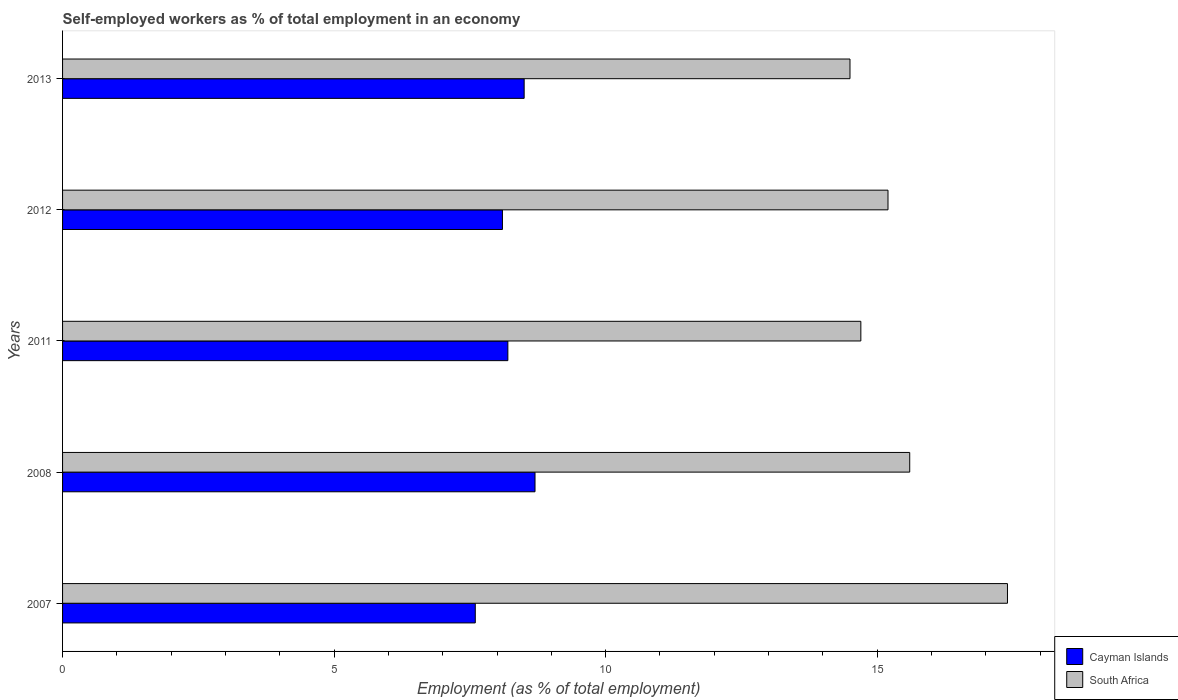How many different coloured bars are there?
Give a very brief answer. 2. How many groups of bars are there?
Make the answer very short. 5. Are the number of bars on each tick of the Y-axis equal?
Give a very brief answer. Yes. How many bars are there on the 4th tick from the top?
Provide a short and direct response. 2. What is the label of the 2nd group of bars from the top?
Provide a short and direct response. 2012. In how many cases, is the number of bars for a given year not equal to the number of legend labels?
Keep it short and to the point. 0. What is the percentage of self-employed workers in South Africa in 2011?
Your response must be concise. 14.7. Across all years, what is the maximum percentage of self-employed workers in South Africa?
Your answer should be very brief. 17.4. In which year was the percentage of self-employed workers in Cayman Islands maximum?
Make the answer very short. 2008. What is the total percentage of self-employed workers in Cayman Islands in the graph?
Make the answer very short. 41.1. What is the difference between the percentage of self-employed workers in Cayman Islands in 2008 and that in 2013?
Keep it short and to the point. 0.2. What is the difference between the percentage of self-employed workers in Cayman Islands in 2007 and the percentage of self-employed workers in South Africa in 2013?
Ensure brevity in your answer.  -6.9. What is the average percentage of self-employed workers in Cayman Islands per year?
Your answer should be compact. 8.22. In the year 2007, what is the difference between the percentage of self-employed workers in South Africa and percentage of self-employed workers in Cayman Islands?
Provide a short and direct response. 9.8. What is the ratio of the percentage of self-employed workers in Cayman Islands in 2011 to that in 2012?
Your answer should be very brief. 1.01. What is the difference between the highest and the second highest percentage of self-employed workers in South Africa?
Keep it short and to the point. 1.8. What is the difference between the highest and the lowest percentage of self-employed workers in South Africa?
Your response must be concise. 2.9. Is the sum of the percentage of self-employed workers in Cayman Islands in 2012 and 2013 greater than the maximum percentage of self-employed workers in South Africa across all years?
Your answer should be very brief. No. What does the 1st bar from the top in 2008 represents?
Keep it short and to the point. South Africa. What does the 2nd bar from the bottom in 2012 represents?
Give a very brief answer. South Africa. How many bars are there?
Provide a succinct answer. 10. Are all the bars in the graph horizontal?
Your response must be concise. Yes. How many years are there in the graph?
Your answer should be compact. 5. Are the values on the major ticks of X-axis written in scientific E-notation?
Your answer should be compact. No. How are the legend labels stacked?
Offer a very short reply. Vertical. What is the title of the graph?
Give a very brief answer. Self-employed workers as % of total employment in an economy. Does "United Kingdom" appear as one of the legend labels in the graph?
Make the answer very short. No. What is the label or title of the X-axis?
Your answer should be very brief. Employment (as % of total employment). What is the Employment (as % of total employment) in Cayman Islands in 2007?
Ensure brevity in your answer.  7.6. What is the Employment (as % of total employment) of South Africa in 2007?
Provide a succinct answer. 17.4. What is the Employment (as % of total employment) of Cayman Islands in 2008?
Ensure brevity in your answer.  8.7. What is the Employment (as % of total employment) of South Africa in 2008?
Your answer should be compact. 15.6. What is the Employment (as % of total employment) in Cayman Islands in 2011?
Make the answer very short. 8.2. What is the Employment (as % of total employment) in South Africa in 2011?
Offer a very short reply. 14.7. What is the Employment (as % of total employment) of Cayman Islands in 2012?
Give a very brief answer. 8.1. What is the Employment (as % of total employment) of South Africa in 2012?
Provide a short and direct response. 15.2. What is the Employment (as % of total employment) in Cayman Islands in 2013?
Ensure brevity in your answer.  8.5. Across all years, what is the maximum Employment (as % of total employment) of Cayman Islands?
Your response must be concise. 8.7. Across all years, what is the maximum Employment (as % of total employment) in South Africa?
Your response must be concise. 17.4. Across all years, what is the minimum Employment (as % of total employment) of Cayman Islands?
Offer a terse response. 7.6. Across all years, what is the minimum Employment (as % of total employment) in South Africa?
Your response must be concise. 14.5. What is the total Employment (as % of total employment) in Cayman Islands in the graph?
Your answer should be very brief. 41.1. What is the total Employment (as % of total employment) in South Africa in the graph?
Your answer should be very brief. 77.4. What is the difference between the Employment (as % of total employment) in Cayman Islands in 2007 and that in 2011?
Your answer should be compact. -0.6. What is the difference between the Employment (as % of total employment) in Cayman Islands in 2008 and that in 2011?
Provide a short and direct response. 0.5. What is the difference between the Employment (as % of total employment) in South Africa in 2008 and that in 2011?
Give a very brief answer. 0.9. What is the difference between the Employment (as % of total employment) of South Africa in 2011 and that in 2012?
Offer a terse response. -0.5. What is the difference between the Employment (as % of total employment) of South Africa in 2011 and that in 2013?
Offer a very short reply. 0.2. What is the difference between the Employment (as % of total employment) in Cayman Islands in 2012 and that in 2013?
Keep it short and to the point. -0.4. What is the difference between the Employment (as % of total employment) in South Africa in 2012 and that in 2013?
Your response must be concise. 0.7. What is the difference between the Employment (as % of total employment) of Cayman Islands in 2007 and the Employment (as % of total employment) of South Africa in 2008?
Your response must be concise. -8. What is the difference between the Employment (as % of total employment) of Cayman Islands in 2007 and the Employment (as % of total employment) of South Africa in 2012?
Give a very brief answer. -7.6. What is the difference between the Employment (as % of total employment) in Cayman Islands in 2007 and the Employment (as % of total employment) in South Africa in 2013?
Keep it short and to the point. -6.9. What is the difference between the Employment (as % of total employment) in Cayman Islands in 2008 and the Employment (as % of total employment) in South Africa in 2011?
Give a very brief answer. -6. What is the difference between the Employment (as % of total employment) of Cayman Islands in 2008 and the Employment (as % of total employment) of South Africa in 2013?
Ensure brevity in your answer.  -5.8. What is the difference between the Employment (as % of total employment) in Cayman Islands in 2011 and the Employment (as % of total employment) in South Africa in 2013?
Your answer should be very brief. -6.3. What is the average Employment (as % of total employment) in Cayman Islands per year?
Your answer should be very brief. 8.22. What is the average Employment (as % of total employment) of South Africa per year?
Keep it short and to the point. 15.48. In the year 2008, what is the difference between the Employment (as % of total employment) in Cayman Islands and Employment (as % of total employment) in South Africa?
Give a very brief answer. -6.9. In the year 2011, what is the difference between the Employment (as % of total employment) of Cayman Islands and Employment (as % of total employment) of South Africa?
Your answer should be very brief. -6.5. In the year 2012, what is the difference between the Employment (as % of total employment) in Cayman Islands and Employment (as % of total employment) in South Africa?
Your answer should be compact. -7.1. What is the ratio of the Employment (as % of total employment) of Cayman Islands in 2007 to that in 2008?
Provide a succinct answer. 0.87. What is the ratio of the Employment (as % of total employment) in South Africa in 2007 to that in 2008?
Your answer should be very brief. 1.12. What is the ratio of the Employment (as % of total employment) in Cayman Islands in 2007 to that in 2011?
Provide a succinct answer. 0.93. What is the ratio of the Employment (as % of total employment) of South Africa in 2007 to that in 2011?
Provide a succinct answer. 1.18. What is the ratio of the Employment (as % of total employment) of Cayman Islands in 2007 to that in 2012?
Offer a very short reply. 0.94. What is the ratio of the Employment (as % of total employment) in South Africa in 2007 to that in 2012?
Your answer should be very brief. 1.14. What is the ratio of the Employment (as % of total employment) of Cayman Islands in 2007 to that in 2013?
Make the answer very short. 0.89. What is the ratio of the Employment (as % of total employment) in South Africa in 2007 to that in 2013?
Provide a short and direct response. 1.2. What is the ratio of the Employment (as % of total employment) in Cayman Islands in 2008 to that in 2011?
Make the answer very short. 1.06. What is the ratio of the Employment (as % of total employment) of South Africa in 2008 to that in 2011?
Provide a short and direct response. 1.06. What is the ratio of the Employment (as % of total employment) in Cayman Islands in 2008 to that in 2012?
Provide a succinct answer. 1.07. What is the ratio of the Employment (as % of total employment) of South Africa in 2008 to that in 2012?
Your response must be concise. 1.03. What is the ratio of the Employment (as % of total employment) in Cayman Islands in 2008 to that in 2013?
Give a very brief answer. 1.02. What is the ratio of the Employment (as % of total employment) in South Africa in 2008 to that in 2013?
Provide a succinct answer. 1.08. What is the ratio of the Employment (as % of total employment) in Cayman Islands in 2011 to that in 2012?
Make the answer very short. 1.01. What is the ratio of the Employment (as % of total employment) of South Africa in 2011 to that in 2012?
Provide a succinct answer. 0.97. What is the ratio of the Employment (as % of total employment) of Cayman Islands in 2011 to that in 2013?
Provide a short and direct response. 0.96. What is the ratio of the Employment (as % of total employment) of South Africa in 2011 to that in 2013?
Make the answer very short. 1.01. What is the ratio of the Employment (as % of total employment) of Cayman Islands in 2012 to that in 2013?
Keep it short and to the point. 0.95. What is the ratio of the Employment (as % of total employment) of South Africa in 2012 to that in 2013?
Keep it short and to the point. 1.05. What is the difference between the highest and the second highest Employment (as % of total employment) in Cayman Islands?
Provide a succinct answer. 0.2. What is the difference between the highest and the lowest Employment (as % of total employment) of Cayman Islands?
Your answer should be very brief. 1.1. What is the difference between the highest and the lowest Employment (as % of total employment) in South Africa?
Your answer should be very brief. 2.9. 